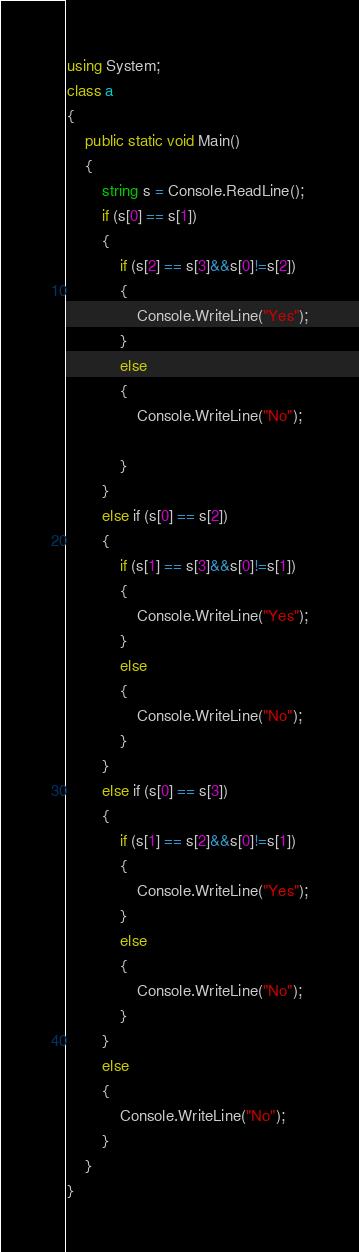<code> <loc_0><loc_0><loc_500><loc_500><_C#_>using System;
class a
{
    public static void Main()
    {
        string s = Console.ReadLine();
        if (s[0] == s[1])
        {
            if (s[2] == s[3]&&s[0]!=s[2])
            {
                Console.WriteLine("Yes");
            }
            else
            {
                Console.WriteLine("No");

            }
        }
        else if (s[0] == s[2])
        {
            if (s[1] == s[3]&&s[0]!=s[1])
            {
                Console.WriteLine("Yes");
            }
            else
            {
                Console.WriteLine("No");
            }
        }
        else if (s[0] == s[3])
        {
            if (s[1] == s[2]&&s[0]!=s[1])
            {
                Console.WriteLine("Yes");
            }
            else
            {
                Console.WriteLine("No");
            }
        }
        else
        {
            Console.WriteLine("No");
        }
    }
}</code> 